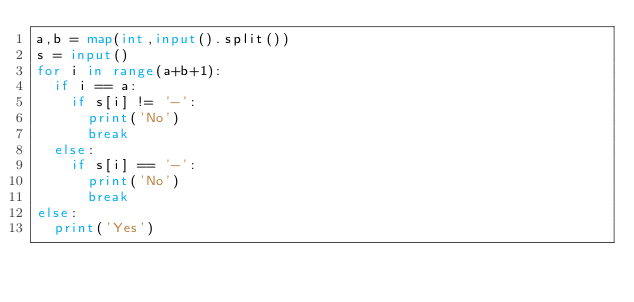Convert code to text. <code><loc_0><loc_0><loc_500><loc_500><_Python_>a,b = map(int,input().split())
s = input()
for i in range(a+b+1):
  if i == a:
    if s[i] != '-':
      print('No')
      break
  else:
    if s[i] == '-':
      print('No')
      break
else:
  print('Yes')</code> 